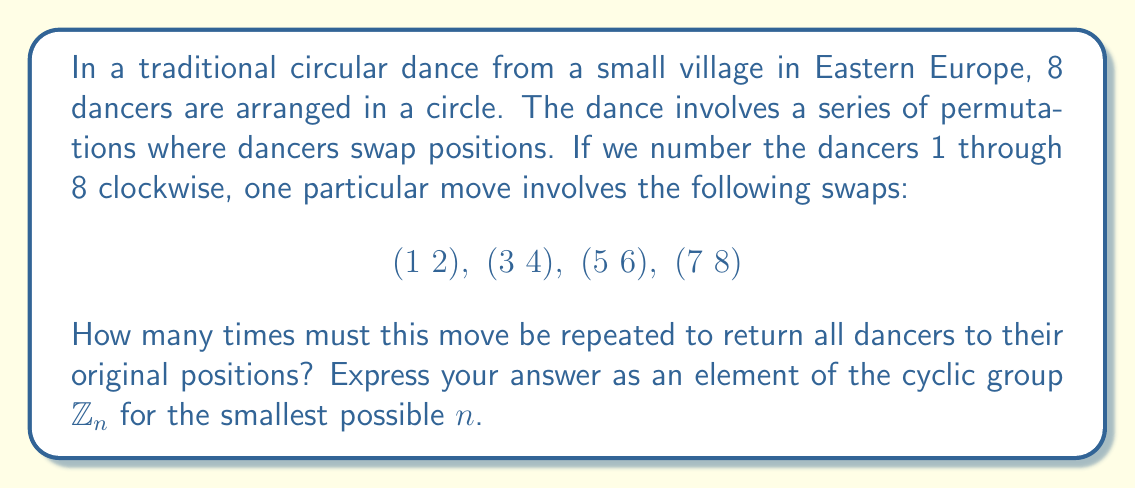Provide a solution to this math problem. Let's approach this step-by-step:

1) First, we need to understand what this permutation does. It swaps adjacent pairs of dancers.

2) In cycle notation, this permutation can be written as $(1 2)(3 4)(5 6)(7 8)$.

3) To find how many times this needs to be repeated, we need to find the order of this permutation. The order is the smallest positive integer $k$ such that $\sigma^k = e$, where $e$ is the identity permutation.

4) Each swap $(a b)$ has order 2, meaning if you do it twice, you get back to where you started.

5) Since all these swaps are disjoint (they don't share any elements), the order of the entire permutation will be the least common multiple (LCM) of the orders of each swap.

6) The order of each swap is 2, so the order of the entire permutation is also 2.

7) This means that after applying this move twice, all dancers will be back in their original positions.

8) In the language of cyclic groups, we can express this as an element of $\mathbb{Z}_2$, which is the cyclic group of order 2.

9) In $\mathbb{Z}_2$, we have:
   $$0 \equiv \text{identity permutation}$$
   $$1 \equiv \text{our dance move}$$

10) Applying the move twice is equivalent to $1 + 1 \equiv 0 \pmod{2}$

Therefore, the smallest $n$ for which we can express this in $\mathbb{Z}_n$ is 2.
Answer: $1 \in \mathbb{Z}_2$ 